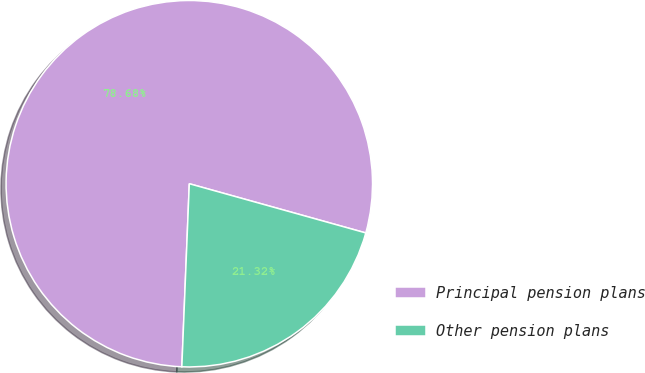Convert chart. <chart><loc_0><loc_0><loc_500><loc_500><pie_chart><fcel>Principal pension plans<fcel>Other pension plans<nl><fcel>78.68%<fcel>21.32%<nl></chart> 